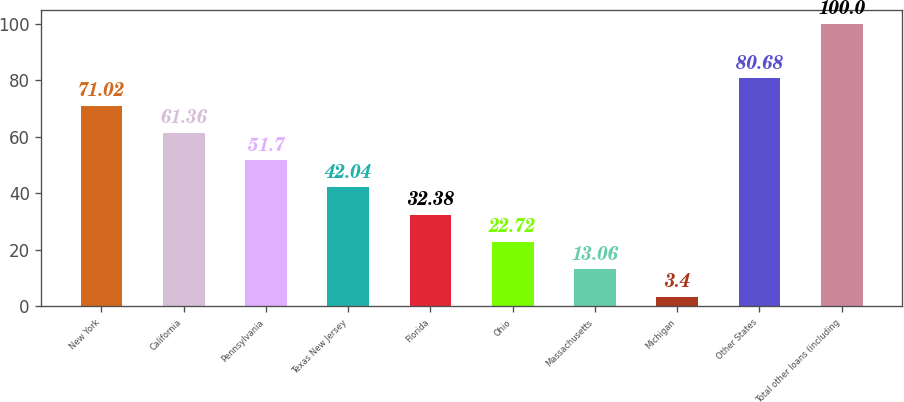<chart> <loc_0><loc_0><loc_500><loc_500><bar_chart><fcel>New York<fcel>California<fcel>Pennsylvania<fcel>Texas New Jersey<fcel>Florida<fcel>Ohio<fcel>Massachusetts<fcel>Michigan<fcel>Other States<fcel>Total other loans (including<nl><fcel>71.02<fcel>61.36<fcel>51.7<fcel>42.04<fcel>32.38<fcel>22.72<fcel>13.06<fcel>3.4<fcel>80.68<fcel>100<nl></chart> 